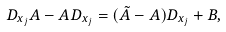Convert formula to latex. <formula><loc_0><loc_0><loc_500><loc_500>D _ { x _ { j } } A - A D _ { x _ { j } } = ( \tilde { A } - A ) D _ { x _ { j } } + B ,</formula> 